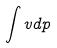<formula> <loc_0><loc_0><loc_500><loc_500>\int v d p</formula> 